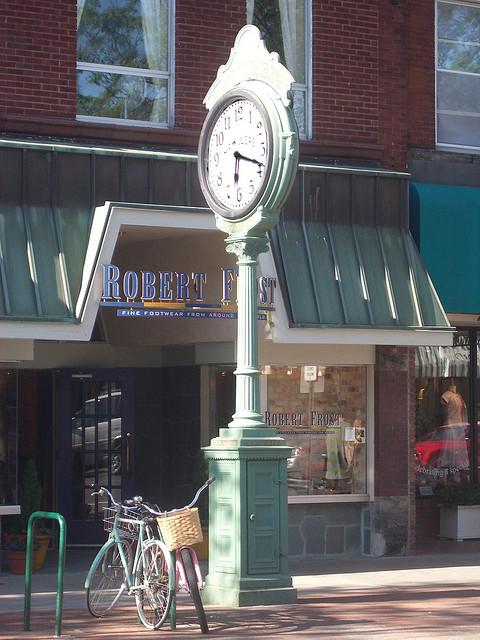Are there bike racks on the street?
Keep it brief. Yes. What time is it?
Keep it brief. 6:18. Who has the key to open the clock?
Write a very short answer. Owner. 